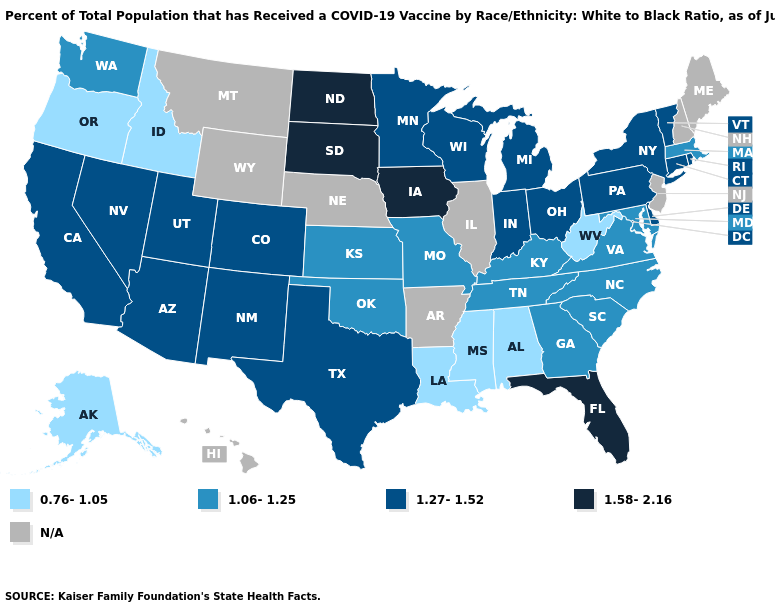Does the first symbol in the legend represent the smallest category?
Give a very brief answer. Yes. Among the states that border Oregon , does Nevada have the highest value?
Keep it brief. Yes. Among the states that border Mississippi , which have the lowest value?
Give a very brief answer. Alabama, Louisiana. Does Tennessee have the highest value in the USA?
Write a very short answer. No. Among the states that border South Dakota , does Minnesota have the highest value?
Concise answer only. No. Which states have the lowest value in the West?
Short answer required. Alaska, Idaho, Oregon. Among the states that border California , which have the highest value?
Write a very short answer. Arizona, Nevada. Does Vermont have the lowest value in the Northeast?
Keep it brief. No. What is the lowest value in the USA?
Write a very short answer. 0.76-1.05. Among the states that border Minnesota , which have the highest value?
Give a very brief answer. Iowa, North Dakota, South Dakota. Among the states that border Florida , which have the lowest value?
Answer briefly. Alabama. 